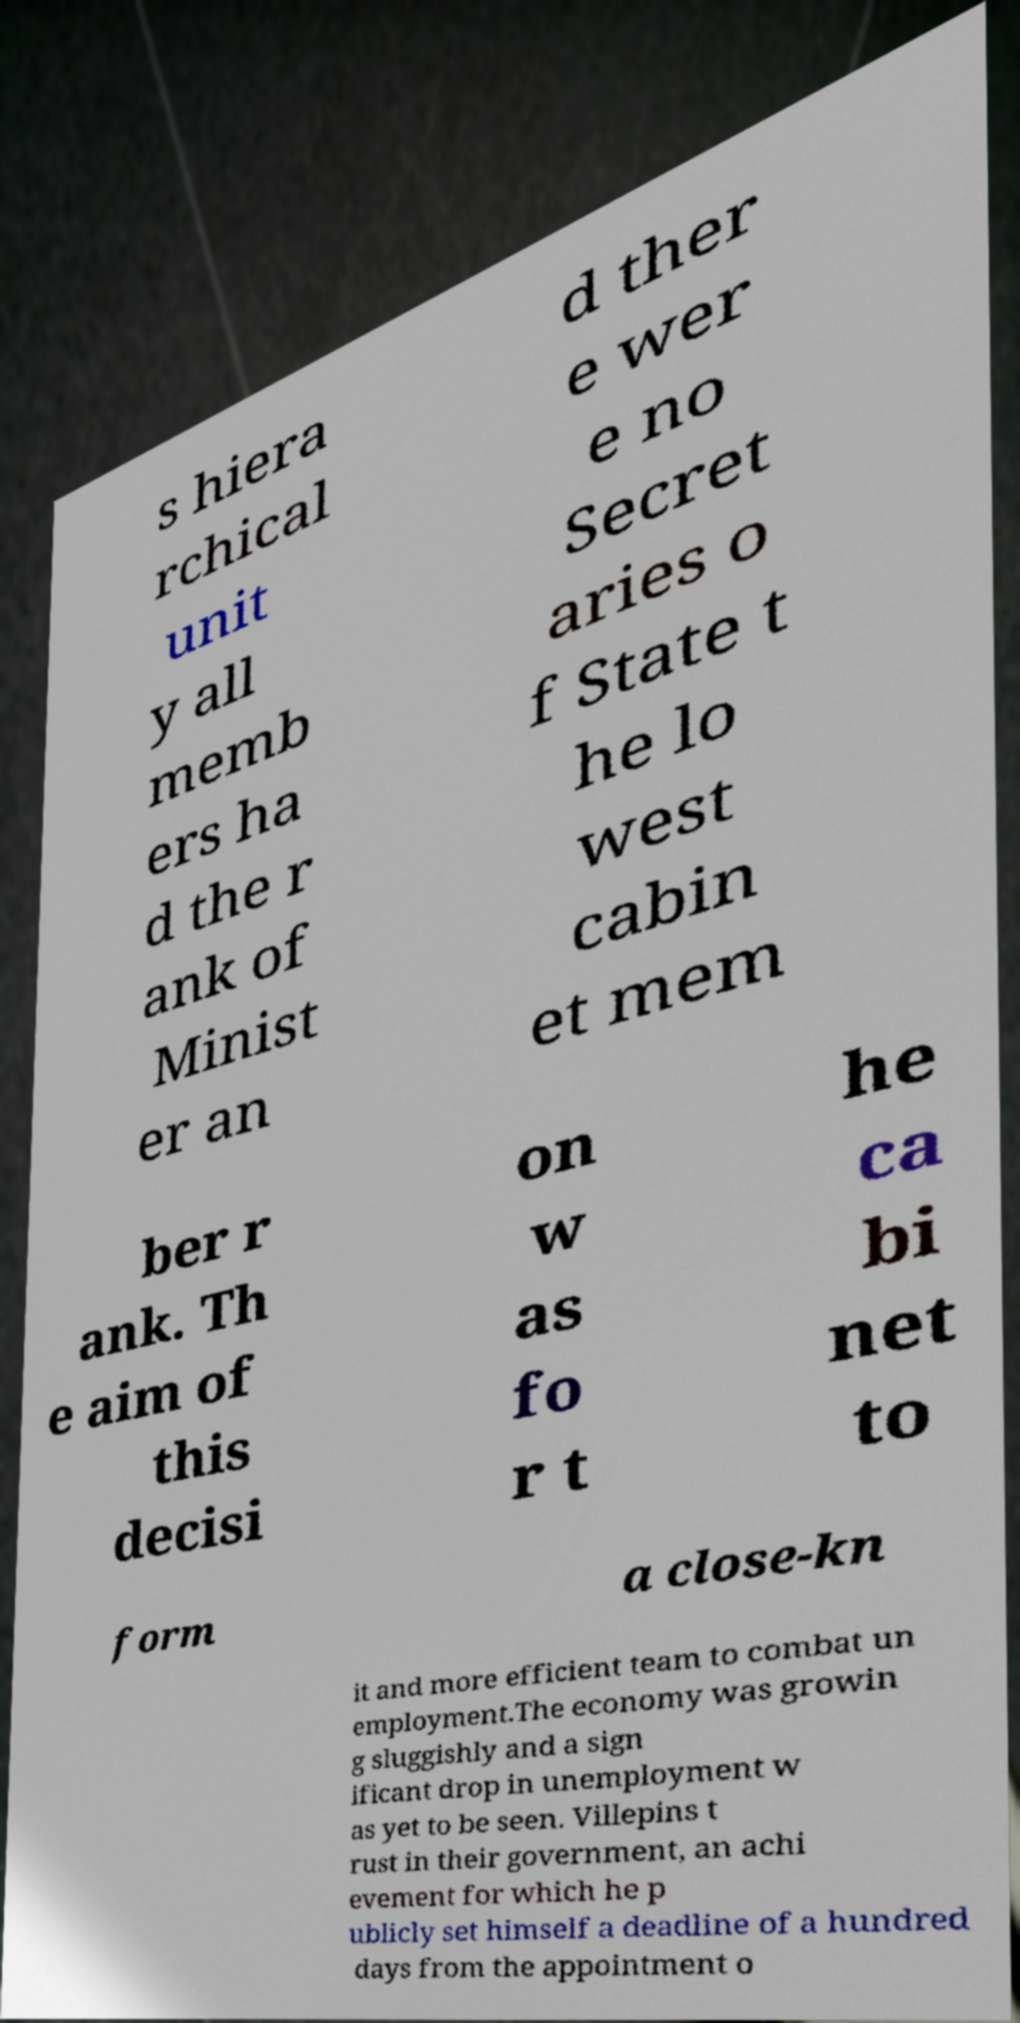Could you extract and type out the text from this image? s hiera rchical unit y all memb ers ha d the r ank of Minist er an d ther e wer e no Secret aries o f State t he lo west cabin et mem ber r ank. Th e aim of this decisi on w as fo r t he ca bi net to form a close-kn it and more efficient team to combat un employment.The economy was growin g sluggishly and a sign ificant drop in unemployment w as yet to be seen. Villepins t rust in their government, an achi evement for which he p ublicly set himself a deadline of a hundred days from the appointment o 